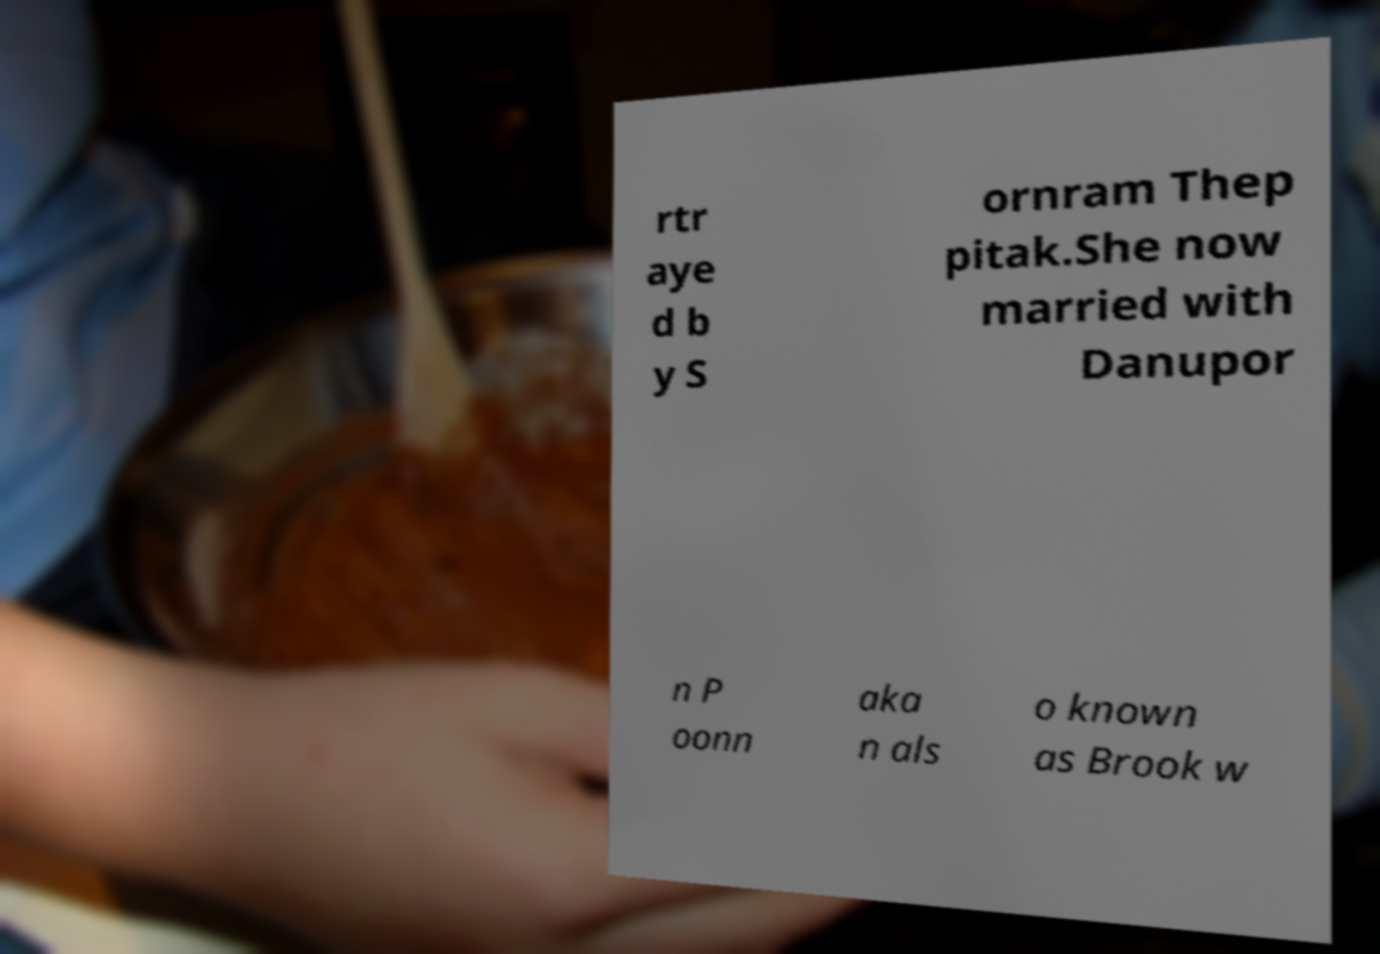For documentation purposes, I need the text within this image transcribed. Could you provide that? rtr aye d b y S ornram Thep pitak.She now married with Danupor n P oonn aka n als o known as Brook w 